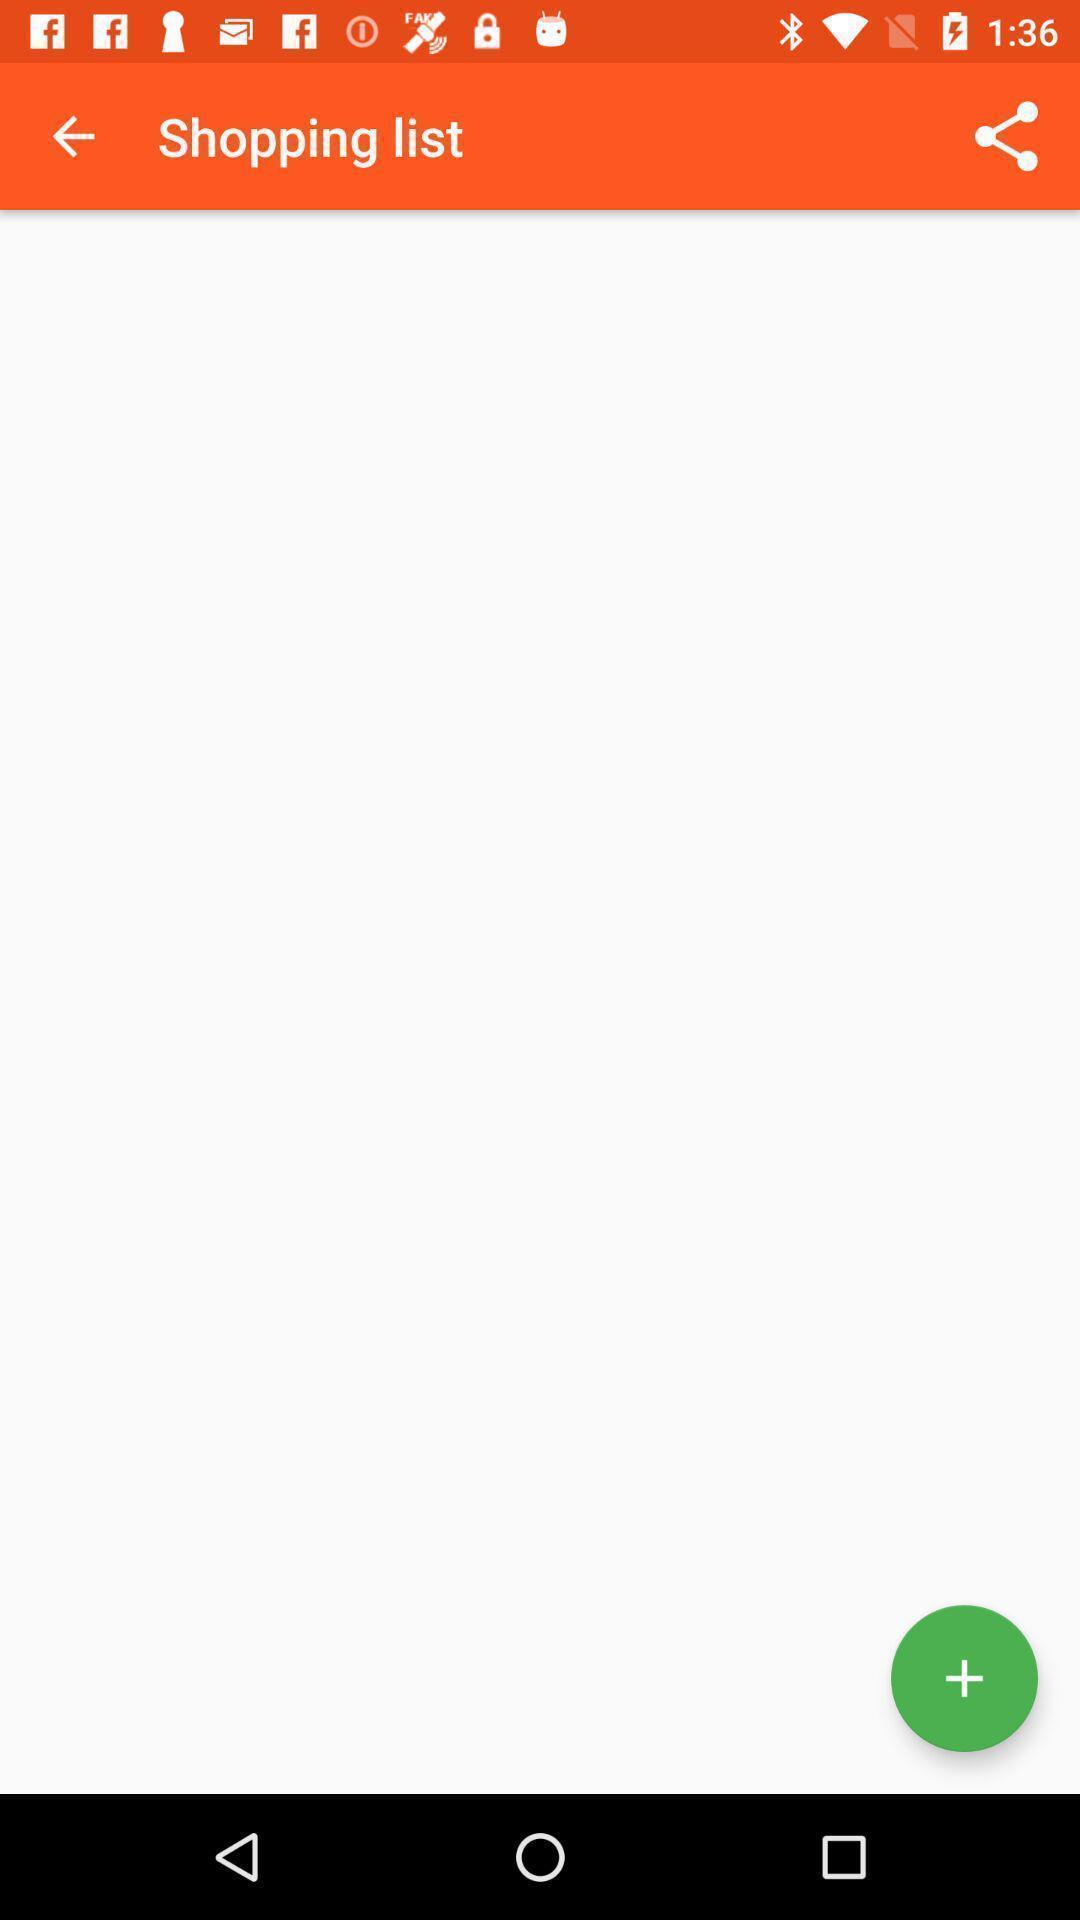Describe the key features of this screenshot. Screen displaying shopping list with share option. 